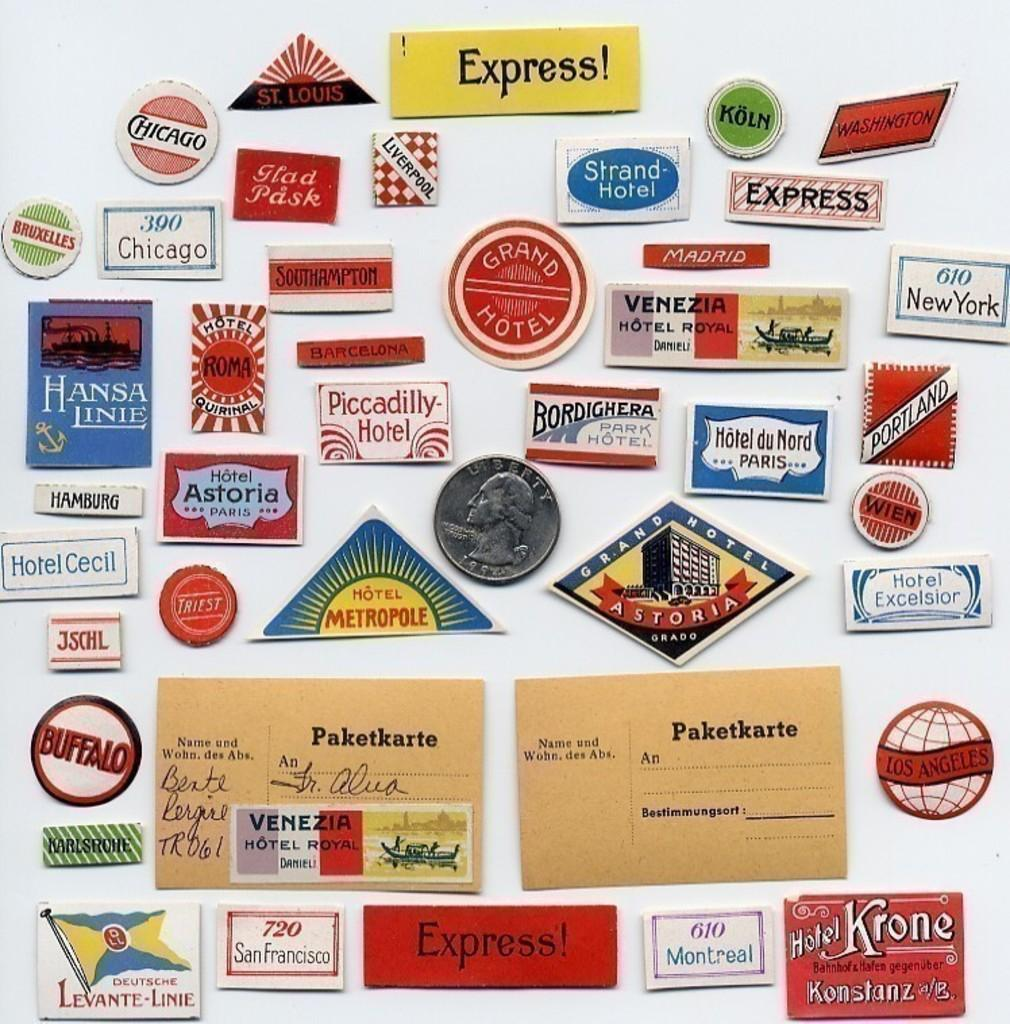<image>
Render a clear and concise summary of the photo. many patches for various places like Piccadilly Hotel and Madrid 